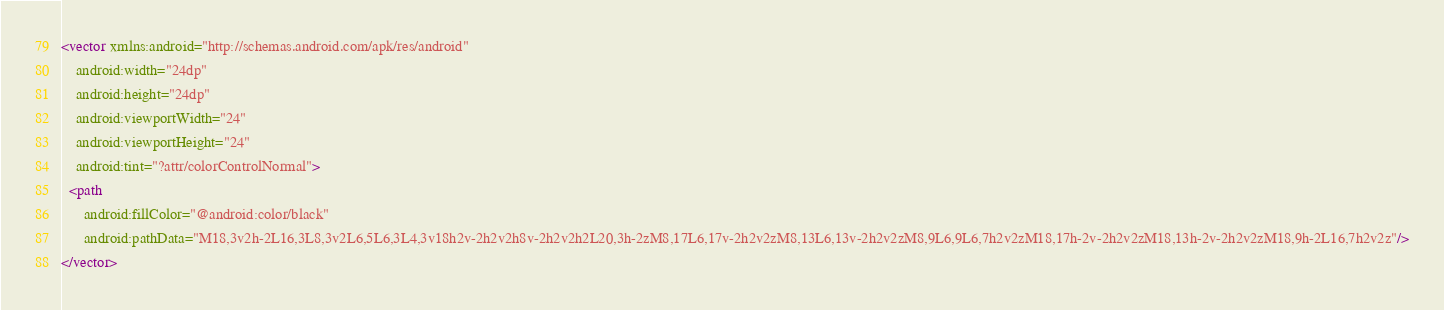Convert code to text. <code><loc_0><loc_0><loc_500><loc_500><_XML_><vector xmlns:android="http://schemas.android.com/apk/res/android"
    android:width="24dp"
    android:height="24dp"
    android:viewportWidth="24"
    android:viewportHeight="24"
    android:tint="?attr/colorControlNormal">
  <path
      android:fillColor="@android:color/black"
      android:pathData="M18,3v2h-2L16,3L8,3v2L6,5L6,3L4,3v18h2v-2h2v2h8v-2h2v2h2L20,3h-2zM8,17L6,17v-2h2v2zM8,13L6,13v-2h2v2zM8,9L6,9L6,7h2v2zM18,17h-2v-2h2v2zM18,13h-2v-2h2v2zM18,9h-2L16,7h2v2z"/>
</vector>
</code> 